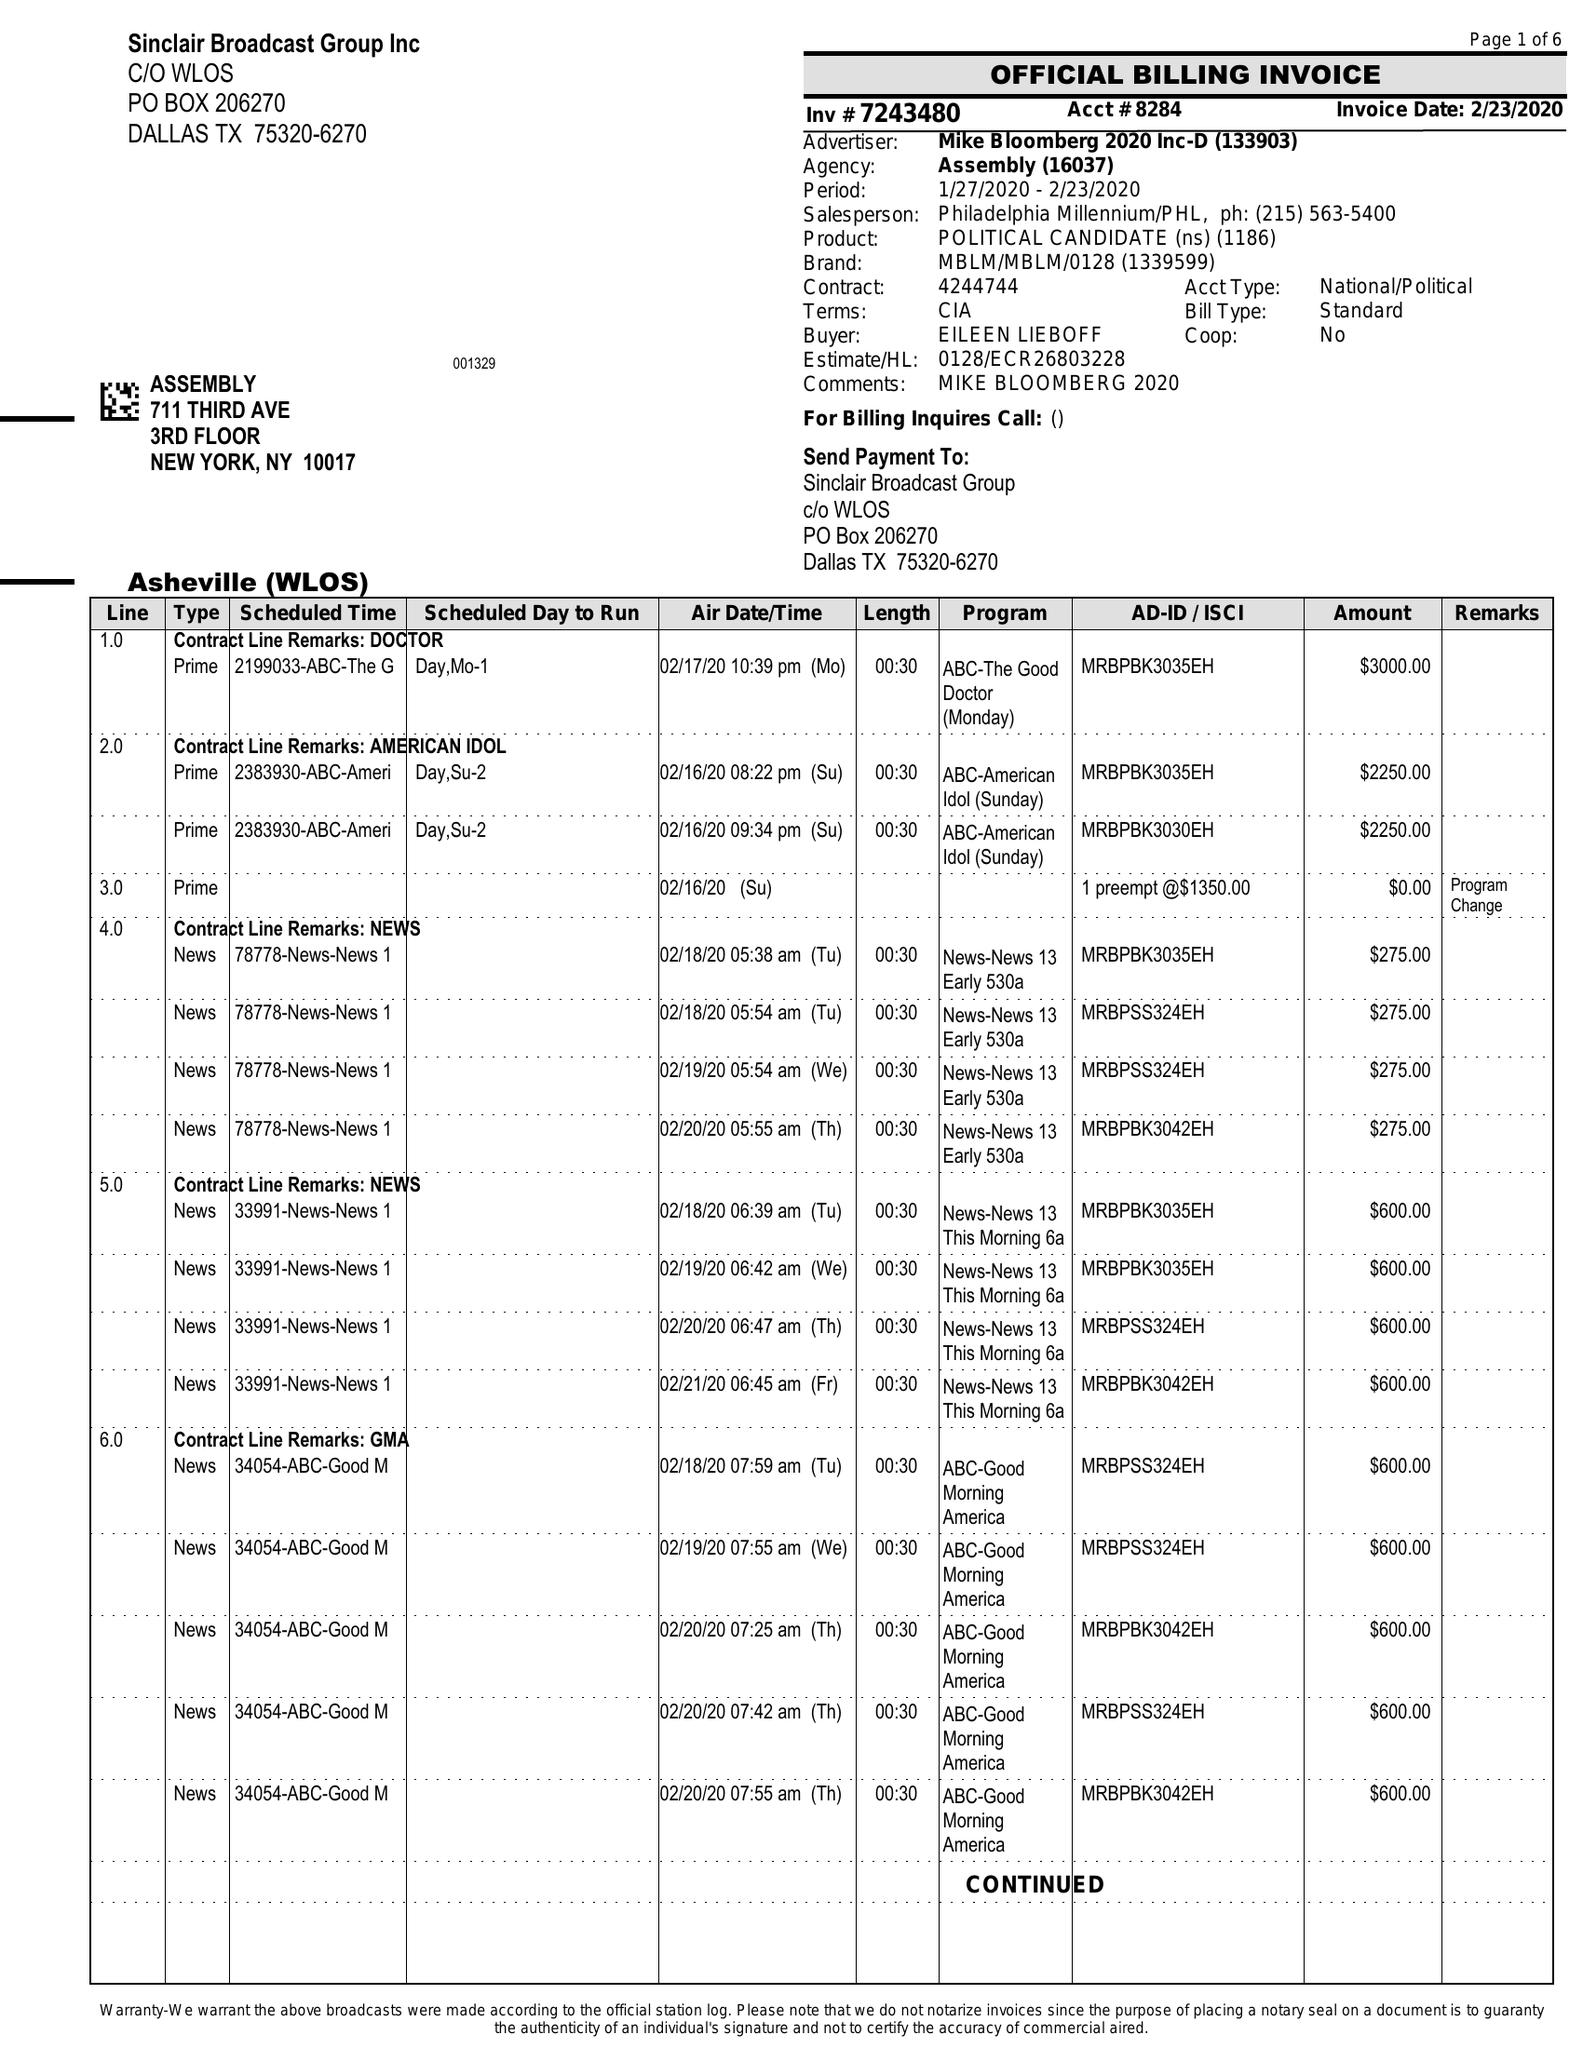What is the value for the gross_amount?
Answer the question using a single word or phrase. 106550.00 